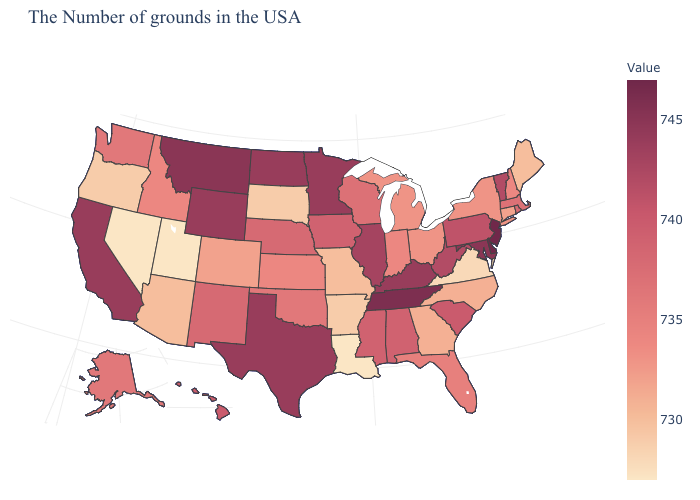Is the legend a continuous bar?
Answer briefly. Yes. Which states have the lowest value in the USA?
Be succinct. Louisiana, Utah, Nevada. Is the legend a continuous bar?
Be succinct. Yes. Does Nebraska have a lower value than New Hampshire?
Concise answer only. No. Is the legend a continuous bar?
Be succinct. Yes. 